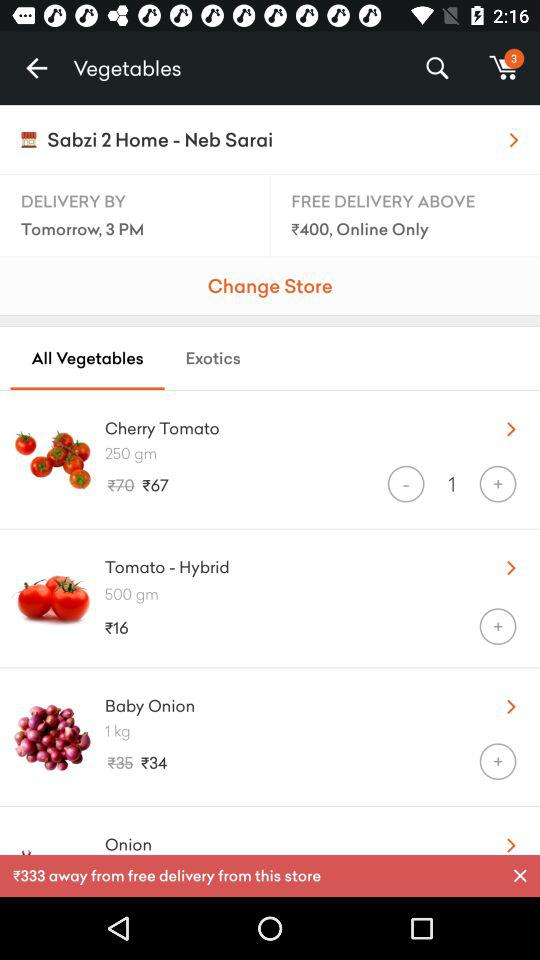What is the price of "Baby Onion" after discount? The price of "Baby Onion" after discount is ₹34. 